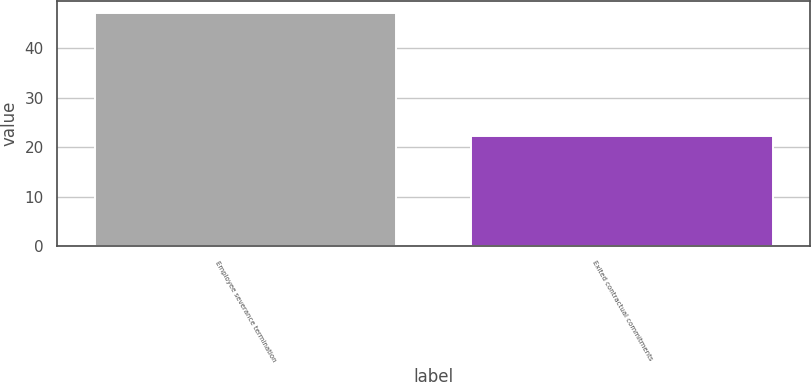Convert chart. <chart><loc_0><loc_0><loc_500><loc_500><bar_chart><fcel>Employee severance termination<fcel>Exited contractual commitments<nl><fcel>47.2<fcel>22.3<nl></chart> 